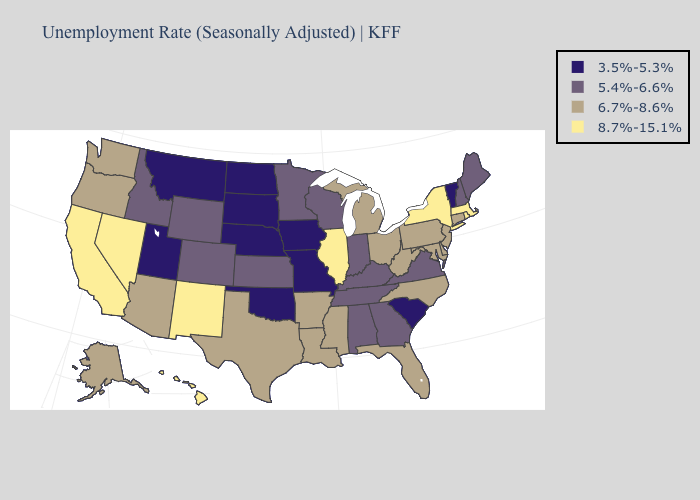What is the value of North Dakota?
Keep it brief. 3.5%-5.3%. Name the states that have a value in the range 6.7%-8.6%?
Quick response, please. Alaska, Arizona, Arkansas, Connecticut, Delaware, Florida, Louisiana, Maryland, Michigan, Mississippi, New Jersey, North Carolina, Ohio, Oregon, Pennsylvania, Texas, Washington, West Virginia. Does the first symbol in the legend represent the smallest category?
Short answer required. Yes. What is the lowest value in states that border Kentucky?
Short answer required. 3.5%-5.3%. Among the states that border Colorado , which have the highest value?
Keep it brief. New Mexico. What is the lowest value in the USA?
Be succinct. 3.5%-5.3%. Name the states that have a value in the range 3.5%-5.3%?
Give a very brief answer. Iowa, Missouri, Montana, Nebraska, North Dakota, Oklahoma, South Carolina, South Dakota, Utah, Vermont. What is the highest value in the South ?
Quick response, please. 6.7%-8.6%. Name the states that have a value in the range 6.7%-8.6%?
Keep it brief. Alaska, Arizona, Arkansas, Connecticut, Delaware, Florida, Louisiana, Maryland, Michigan, Mississippi, New Jersey, North Carolina, Ohio, Oregon, Pennsylvania, Texas, Washington, West Virginia. Does Louisiana have a higher value than Ohio?
Concise answer only. No. Does the first symbol in the legend represent the smallest category?
Be succinct. Yes. Does California have the same value as Oregon?
Be succinct. No. Does the first symbol in the legend represent the smallest category?
Keep it brief. Yes. What is the lowest value in the West?
Give a very brief answer. 3.5%-5.3%. Name the states that have a value in the range 8.7%-15.1%?
Be succinct. California, Hawaii, Illinois, Massachusetts, Nevada, New Mexico, New York, Rhode Island. 